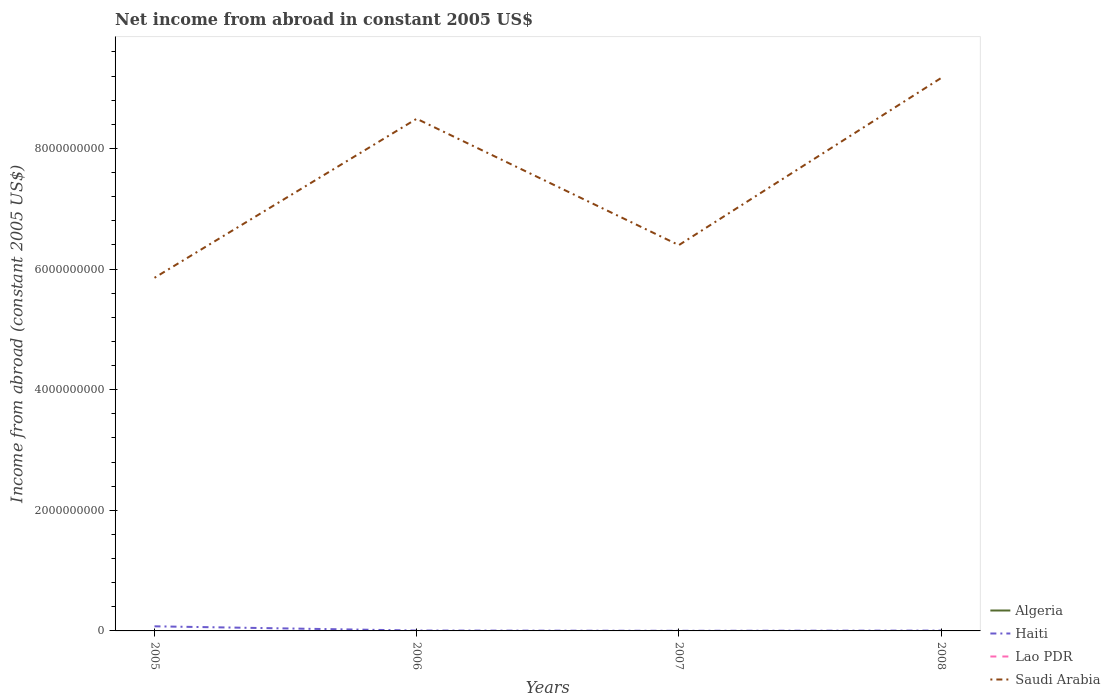How many different coloured lines are there?
Offer a very short reply. 2. Is the number of lines equal to the number of legend labels?
Make the answer very short. No. What is the total net income from abroad in Haiti in the graph?
Offer a very short reply. -3.35e+06. What is the difference between the highest and the second highest net income from abroad in Saudi Arabia?
Provide a succinct answer. 3.31e+09. Are the values on the major ticks of Y-axis written in scientific E-notation?
Keep it short and to the point. No. Does the graph contain grids?
Keep it short and to the point. No. How are the legend labels stacked?
Give a very brief answer. Vertical. What is the title of the graph?
Your answer should be compact. Net income from abroad in constant 2005 US$. Does "Chile" appear as one of the legend labels in the graph?
Provide a short and direct response. No. What is the label or title of the Y-axis?
Your answer should be compact. Income from abroad (constant 2005 US$). What is the Income from abroad (constant 2005 US$) of Haiti in 2005?
Your response must be concise. 7.64e+07. What is the Income from abroad (constant 2005 US$) in Lao PDR in 2005?
Make the answer very short. 0. What is the Income from abroad (constant 2005 US$) in Saudi Arabia in 2005?
Provide a short and direct response. 5.86e+09. What is the Income from abroad (constant 2005 US$) of Haiti in 2006?
Ensure brevity in your answer.  6.46e+06. What is the Income from abroad (constant 2005 US$) of Lao PDR in 2006?
Your answer should be compact. 0. What is the Income from abroad (constant 2005 US$) of Saudi Arabia in 2006?
Provide a short and direct response. 8.49e+09. What is the Income from abroad (constant 2005 US$) in Algeria in 2007?
Offer a very short reply. 0. What is the Income from abroad (constant 2005 US$) of Haiti in 2007?
Provide a short and direct response. 2.19e+06. What is the Income from abroad (constant 2005 US$) in Saudi Arabia in 2007?
Your answer should be compact. 6.40e+09. What is the Income from abroad (constant 2005 US$) in Haiti in 2008?
Offer a very short reply. 5.54e+06. What is the Income from abroad (constant 2005 US$) of Saudi Arabia in 2008?
Give a very brief answer. 9.17e+09. Across all years, what is the maximum Income from abroad (constant 2005 US$) in Haiti?
Your response must be concise. 7.64e+07. Across all years, what is the maximum Income from abroad (constant 2005 US$) in Saudi Arabia?
Your answer should be very brief. 9.17e+09. Across all years, what is the minimum Income from abroad (constant 2005 US$) of Haiti?
Ensure brevity in your answer.  2.19e+06. Across all years, what is the minimum Income from abroad (constant 2005 US$) of Saudi Arabia?
Give a very brief answer. 5.86e+09. What is the total Income from abroad (constant 2005 US$) in Algeria in the graph?
Provide a short and direct response. 0. What is the total Income from abroad (constant 2005 US$) in Haiti in the graph?
Your answer should be compact. 9.06e+07. What is the total Income from abroad (constant 2005 US$) of Lao PDR in the graph?
Offer a very short reply. 0. What is the total Income from abroad (constant 2005 US$) in Saudi Arabia in the graph?
Your answer should be compact. 2.99e+1. What is the difference between the Income from abroad (constant 2005 US$) of Haiti in 2005 and that in 2006?
Give a very brief answer. 6.99e+07. What is the difference between the Income from abroad (constant 2005 US$) of Saudi Arabia in 2005 and that in 2006?
Give a very brief answer. -2.64e+09. What is the difference between the Income from abroad (constant 2005 US$) of Haiti in 2005 and that in 2007?
Give a very brief answer. 7.42e+07. What is the difference between the Income from abroad (constant 2005 US$) in Saudi Arabia in 2005 and that in 2007?
Offer a very short reply. -5.42e+08. What is the difference between the Income from abroad (constant 2005 US$) in Haiti in 2005 and that in 2008?
Ensure brevity in your answer.  7.08e+07. What is the difference between the Income from abroad (constant 2005 US$) of Saudi Arabia in 2005 and that in 2008?
Make the answer very short. -3.31e+09. What is the difference between the Income from abroad (constant 2005 US$) of Haiti in 2006 and that in 2007?
Give a very brief answer. 4.27e+06. What is the difference between the Income from abroad (constant 2005 US$) in Saudi Arabia in 2006 and that in 2007?
Make the answer very short. 2.10e+09. What is the difference between the Income from abroad (constant 2005 US$) in Haiti in 2006 and that in 2008?
Keep it short and to the point. 9.24e+05. What is the difference between the Income from abroad (constant 2005 US$) of Saudi Arabia in 2006 and that in 2008?
Your answer should be compact. -6.75e+08. What is the difference between the Income from abroad (constant 2005 US$) of Haiti in 2007 and that in 2008?
Your answer should be compact. -3.35e+06. What is the difference between the Income from abroad (constant 2005 US$) in Saudi Arabia in 2007 and that in 2008?
Provide a short and direct response. -2.77e+09. What is the difference between the Income from abroad (constant 2005 US$) in Haiti in 2005 and the Income from abroad (constant 2005 US$) in Saudi Arabia in 2006?
Offer a terse response. -8.42e+09. What is the difference between the Income from abroad (constant 2005 US$) in Haiti in 2005 and the Income from abroad (constant 2005 US$) in Saudi Arabia in 2007?
Your answer should be very brief. -6.32e+09. What is the difference between the Income from abroad (constant 2005 US$) in Haiti in 2005 and the Income from abroad (constant 2005 US$) in Saudi Arabia in 2008?
Ensure brevity in your answer.  -9.09e+09. What is the difference between the Income from abroad (constant 2005 US$) of Haiti in 2006 and the Income from abroad (constant 2005 US$) of Saudi Arabia in 2007?
Your response must be concise. -6.39e+09. What is the difference between the Income from abroad (constant 2005 US$) in Haiti in 2006 and the Income from abroad (constant 2005 US$) in Saudi Arabia in 2008?
Ensure brevity in your answer.  -9.16e+09. What is the difference between the Income from abroad (constant 2005 US$) in Haiti in 2007 and the Income from abroad (constant 2005 US$) in Saudi Arabia in 2008?
Provide a succinct answer. -9.16e+09. What is the average Income from abroad (constant 2005 US$) of Algeria per year?
Your response must be concise. 0. What is the average Income from abroad (constant 2005 US$) in Haiti per year?
Your response must be concise. 2.26e+07. What is the average Income from abroad (constant 2005 US$) in Lao PDR per year?
Provide a succinct answer. 0. What is the average Income from abroad (constant 2005 US$) in Saudi Arabia per year?
Provide a succinct answer. 7.48e+09. In the year 2005, what is the difference between the Income from abroad (constant 2005 US$) in Haiti and Income from abroad (constant 2005 US$) in Saudi Arabia?
Keep it short and to the point. -5.78e+09. In the year 2006, what is the difference between the Income from abroad (constant 2005 US$) of Haiti and Income from abroad (constant 2005 US$) of Saudi Arabia?
Your answer should be compact. -8.49e+09. In the year 2007, what is the difference between the Income from abroad (constant 2005 US$) in Haiti and Income from abroad (constant 2005 US$) in Saudi Arabia?
Your answer should be compact. -6.39e+09. In the year 2008, what is the difference between the Income from abroad (constant 2005 US$) in Haiti and Income from abroad (constant 2005 US$) in Saudi Arabia?
Provide a short and direct response. -9.16e+09. What is the ratio of the Income from abroad (constant 2005 US$) of Haiti in 2005 to that in 2006?
Give a very brief answer. 11.82. What is the ratio of the Income from abroad (constant 2005 US$) in Saudi Arabia in 2005 to that in 2006?
Keep it short and to the point. 0.69. What is the ratio of the Income from abroad (constant 2005 US$) in Haiti in 2005 to that in 2007?
Give a very brief answer. 34.84. What is the ratio of the Income from abroad (constant 2005 US$) in Saudi Arabia in 2005 to that in 2007?
Offer a very short reply. 0.92. What is the ratio of the Income from abroad (constant 2005 US$) of Haiti in 2005 to that in 2008?
Your answer should be very brief. 13.79. What is the ratio of the Income from abroad (constant 2005 US$) in Saudi Arabia in 2005 to that in 2008?
Make the answer very short. 0.64. What is the ratio of the Income from abroad (constant 2005 US$) in Haiti in 2006 to that in 2007?
Offer a very short reply. 2.95. What is the ratio of the Income from abroad (constant 2005 US$) of Saudi Arabia in 2006 to that in 2007?
Ensure brevity in your answer.  1.33. What is the ratio of the Income from abroad (constant 2005 US$) of Haiti in 2006 to that in 2008?
Your response must be concise. 1.17. What is the ratio of the Income from abroad (constant 2005 US$) of Saudi Arabia in 2006 to that in 2008?
Offer a terse response. 0.93. What is the ratio of the Income from abroad (constant 2005 US$) of Haiti in 2007 to that in 2008?
Provide a short and direct response. 0.4. What is the ratio of the Income from abroad (constant 2005 US$) of Saudi Arabia in 2007 to that in 2008?
Give a very brief answer. 0.7. What is the difference between the highest and the second highest Income from abroad (constant 2005 US$) of Haiti?
Ensure brevity in your answer.  6.99e+07. What is the difference between the highest and the second highest Income from abroad (constant 2005 US$) in Saudi Arabia?
Keep it short and to the point. 6.75e+08. What is the difference between the highest and the lowest Income from abroad (constant 2005 US$) of Haiti?
Make the answer very short. 7.42e+07. What is the difference between the highest and the lowest Income from abroad (constant 2005 US$) in Saudi Arabia?
Offer a terse response. 3.31e+09. 